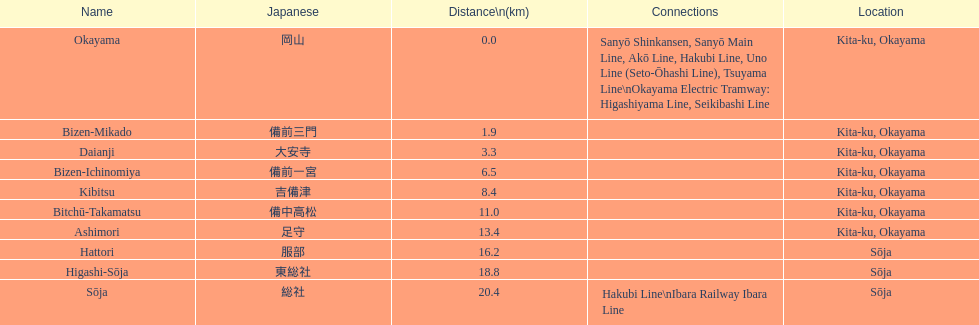0 kilometers away? Bizen-Mikado. 